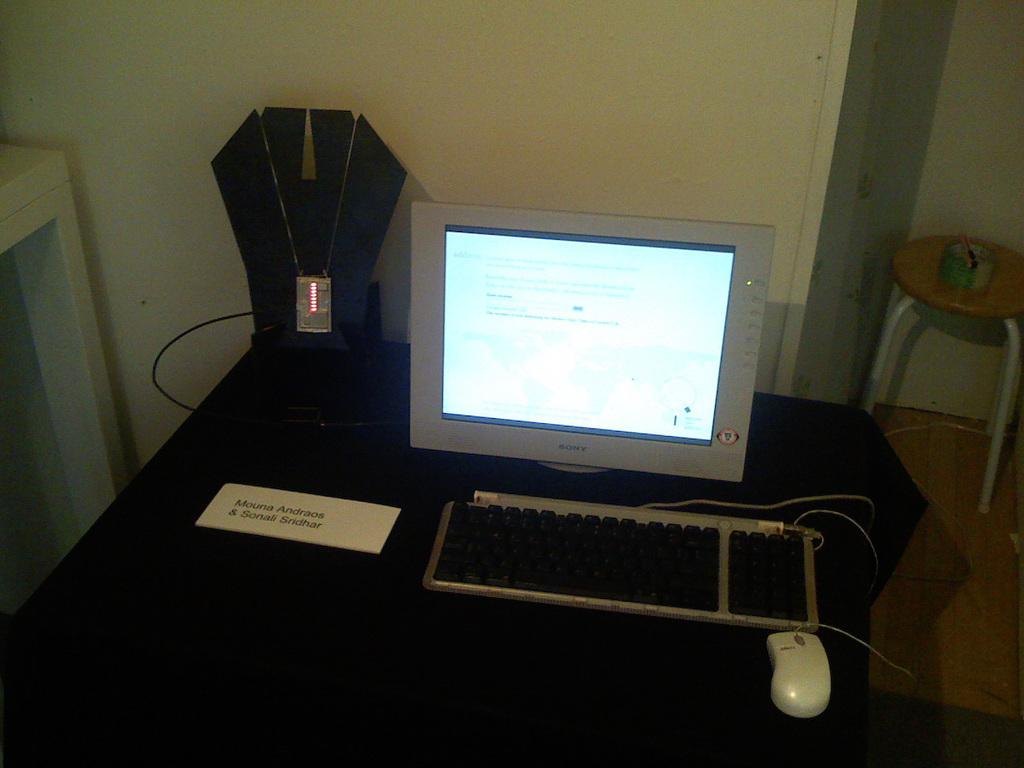What type of furniture is in the image? There is a table in the image. What electronic device is on the table? A keyboard, a mouse, and a monitor are on the table. Is there any identification on the table? Yes, there is a name card on the table. What is located near the table? There is a tape on a nearby table. What can be seen in the background of the image? A wall is visible in the background of the image. What type of can is visible on the table in the image? There is no can present on the table in the image. Is there a box of tissues on the table in the image? There is no box of tissues mentioned in the provided facts about the image. 